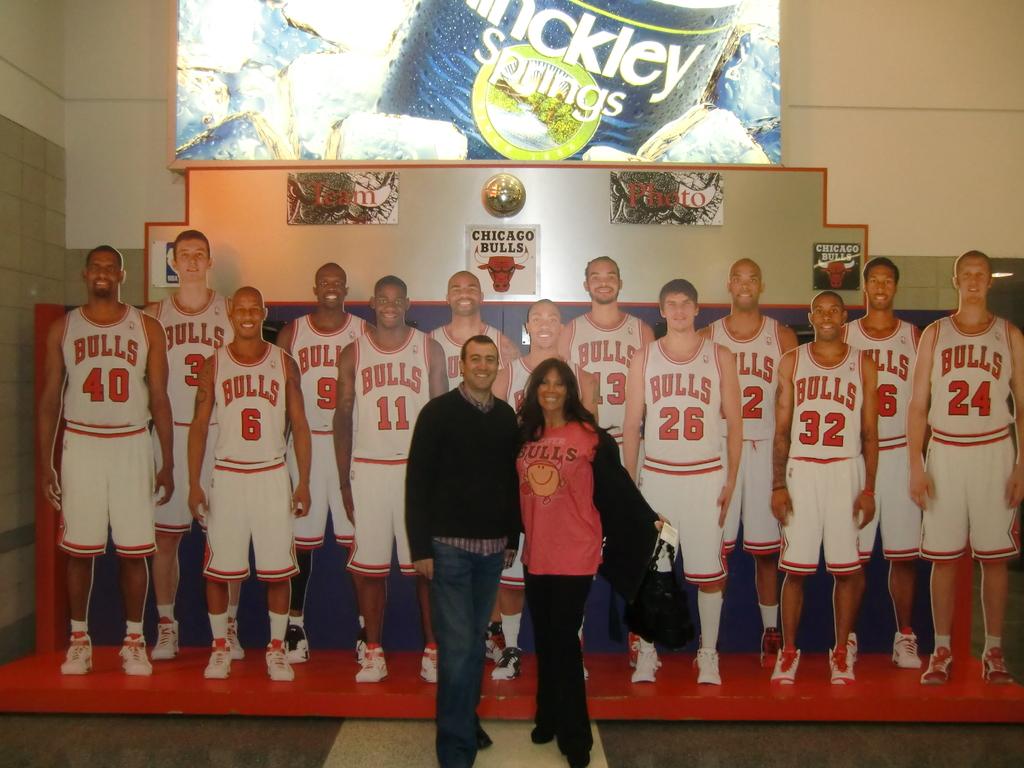What team do those players play for?
Your response must be concise. Bulls. 